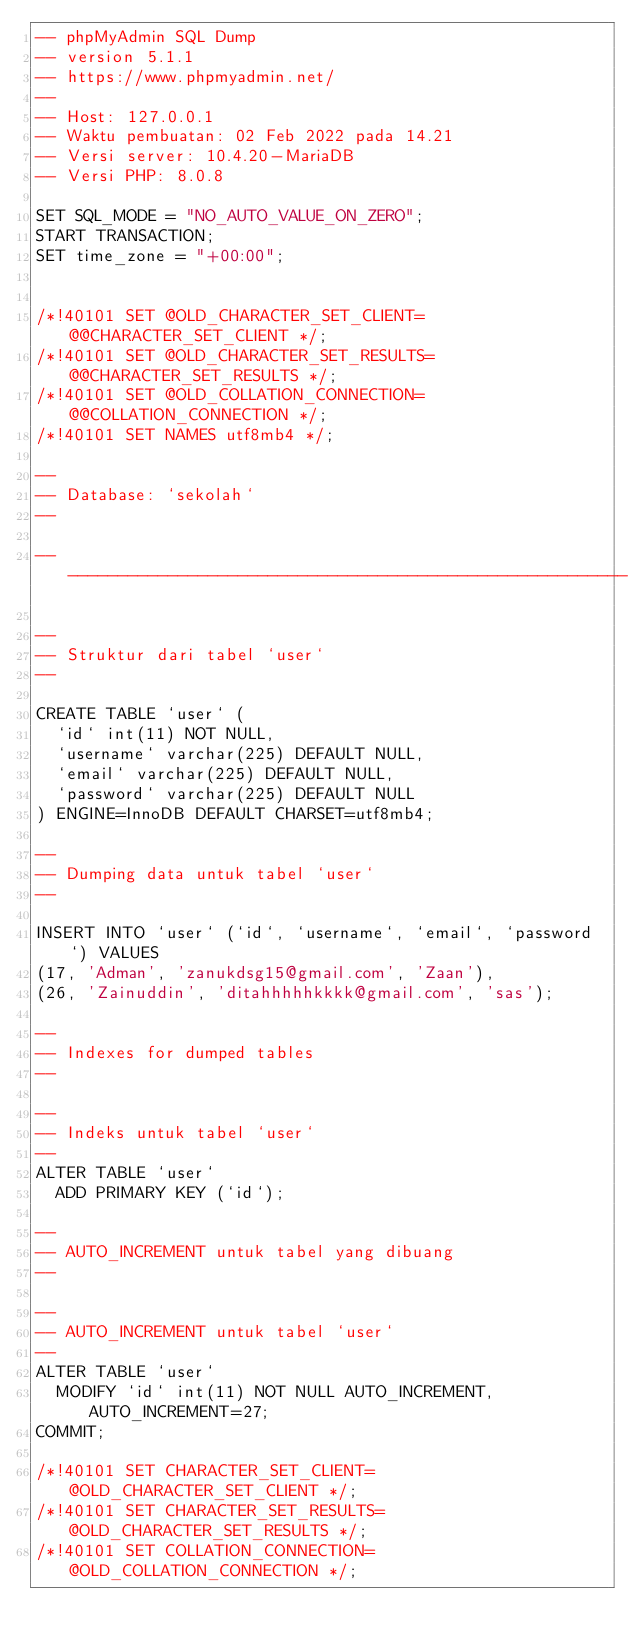Convert code to text. <code><loc_0><loc_0><loc_500><loc_500><_SQL_>-- phpMyAdmin SQL Dump
-- version 5.1.1
-- https://www.phpmyadmin.net/
--
-- Host: 127.0.0.1
-- Waktu pembuatan: 02 Feb 2022 pada 14.21
-- Versi server: 10.4.20-MariaDB
-- Versi PHP: 8.0.8

SET SQL_MODE = "NO_AUTO_VALUE_ON_ZERO";
START TRANSACTION;
SET time_zone = "+00:00";


/*!40101 SET @OLD_CHARACTER_SET_CLIENT=@@CHARACTER_SET_CLIENT */;
/*!40101 SET @OLD_CHARACTER_SET_RESULTS=@@CHARACTER_SET_RESULTS */;
/*!40101 SET @OLD_COLLATION_CONNECTION=@@COLLATION_CONNECTION */;
/*!40101 SET NAMES utf8mb4 */;

--
-- Database: `sekolah`
--

-- --------------------------------------------------------

--
-- Struktur dari tabel `user`
--

CREATE TABLE `user` (
  `id` int(11) NOT NULL,
  `username` varchar(225) DEFAULT NULL,
  `email` varchar(225) DEFAULT NULL,
  `password` varchar(225) DEFAULT NULL
) ENGINE=InnoDB DEFAULT CHARSET=utf8mb4;

--
-- Dumping data untuk tabel `user`
--

INSERT INTO `user` (`id`, `username`, `email`, `password`) VALUES
(17, 'Adman', 'zanukdsg15@gmail.com', 'Zaan'),
(26, 'Zainuddin', 'ditahhhhhkkkk@gmail.com', 'sas');

--
-- Indexes for dumped tables
--

--
-- Indeks untuk tabel `user`
--
ALTER TABLE `user`
  ADD PRIMARY KEY (`id`);

--
-- AUTO_INCREMENT untuk tabel yang dibuang
--

--
-- AUTO_INCREMENT untuk tabel `user`
--
ALTER TABLE `user`
  MODIFY `id` int(11) NOT NULL AUTO_INCREMENT, AUTO_INCREMENT=27;
COMMIT;

/*!40101 SET CHARACTER_SET_CLIENT=@OLD_CHARACTER_SET_CLIENT */;
/*!40101 SET CHARACTER_SET_RESULTS=@OLD_CHARACTER_SET_RESULTS */;
/*!40101 SET COLLATION_CONNECTION=@OLD_COLLATION_CONNECTION */;
</code> 